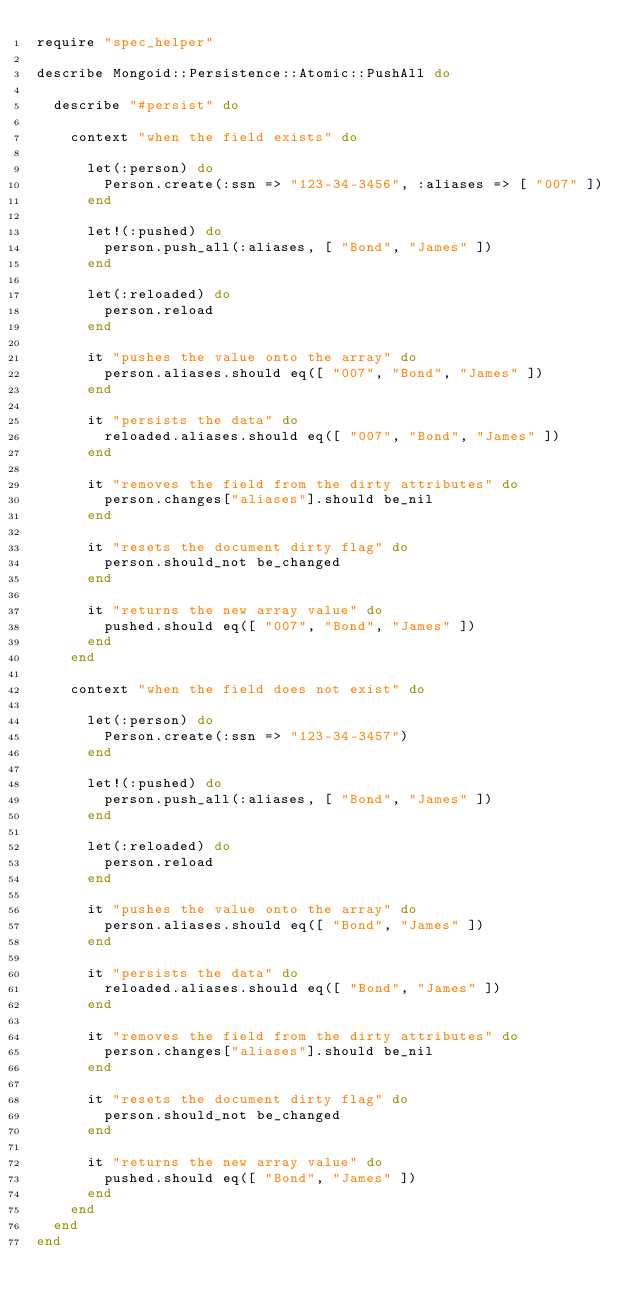<code> <loc_0><loc_0><loc_500><loc_500><_Ruby_>require "spec_helper"

describe Mongoid::Persistence::Atomic::PushAll do

  describe "#persist" do

    context "when the field exists" do

      let(:person) do
        Person.create(:ssn => "123-34-3456", :aliases => [ "007" ])
      end

      let!(:pushed) do
        person.push_all(:aliases, [ "Bond", "James" ])
      end

      let(:reloaded) do
        person.reload
      end

      it "pushes the value onto the array" do
        person.aliases.should eq([ "007", "Bond", "James" ])
      end

      it "persists the data" do
        reloaded.aliases.should eq([ "007", "Bond", "James" ])
      end

      it "removes the field from the dirty attributes" do
        person.changes["aliases"].should be_nil
      end

      it "resets the document dirty flag" do
        person.should_not be_changed
      end

      it "returns the new array value" do
        pushed.should eq([ "007", "Bond", "James" ])
      end
    end

    context "when the field does not exist" do

      let(:person) do
        Person.create(:ssn => "123-34-3457")
      end

      let!(:pushed) do
        person.push_all(:aliases, [ "Bond", "James" ])
      end

      let(:reloaded) do
        person.reload
      end

      it "pushes the value onto the array" do
        person.aliases.should eq([ "Bond", "James" ])
      end

      it "persists the data" do
        reloaded.aliases.should eq([ "Bond", "James" ])
      end

      it "removes the field from the dirty attributes" do
        person.changes["aliases"].should be_nil
      end

      it "resets the document dirty flag" do
        person.should_not be_changed
      end

      it "returns the new array value" do
        pushed.should eq([ "Bond", "James" ])
      end
    end
  end
end
</code> 